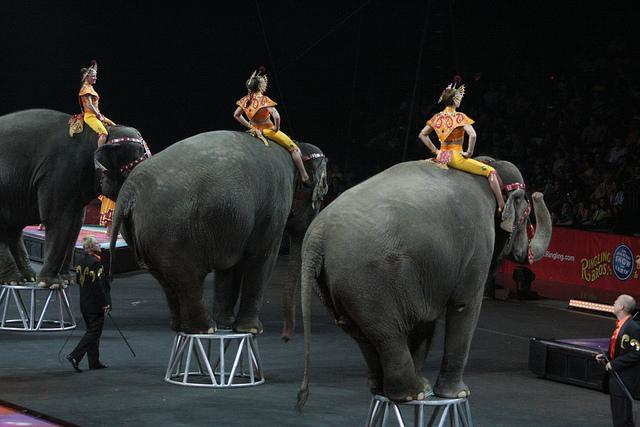What will the man do to the elephants with the sticks he holds?

Choices:
A) kill them
B) poke them
C) mesmerize them
D) feed them poke them 